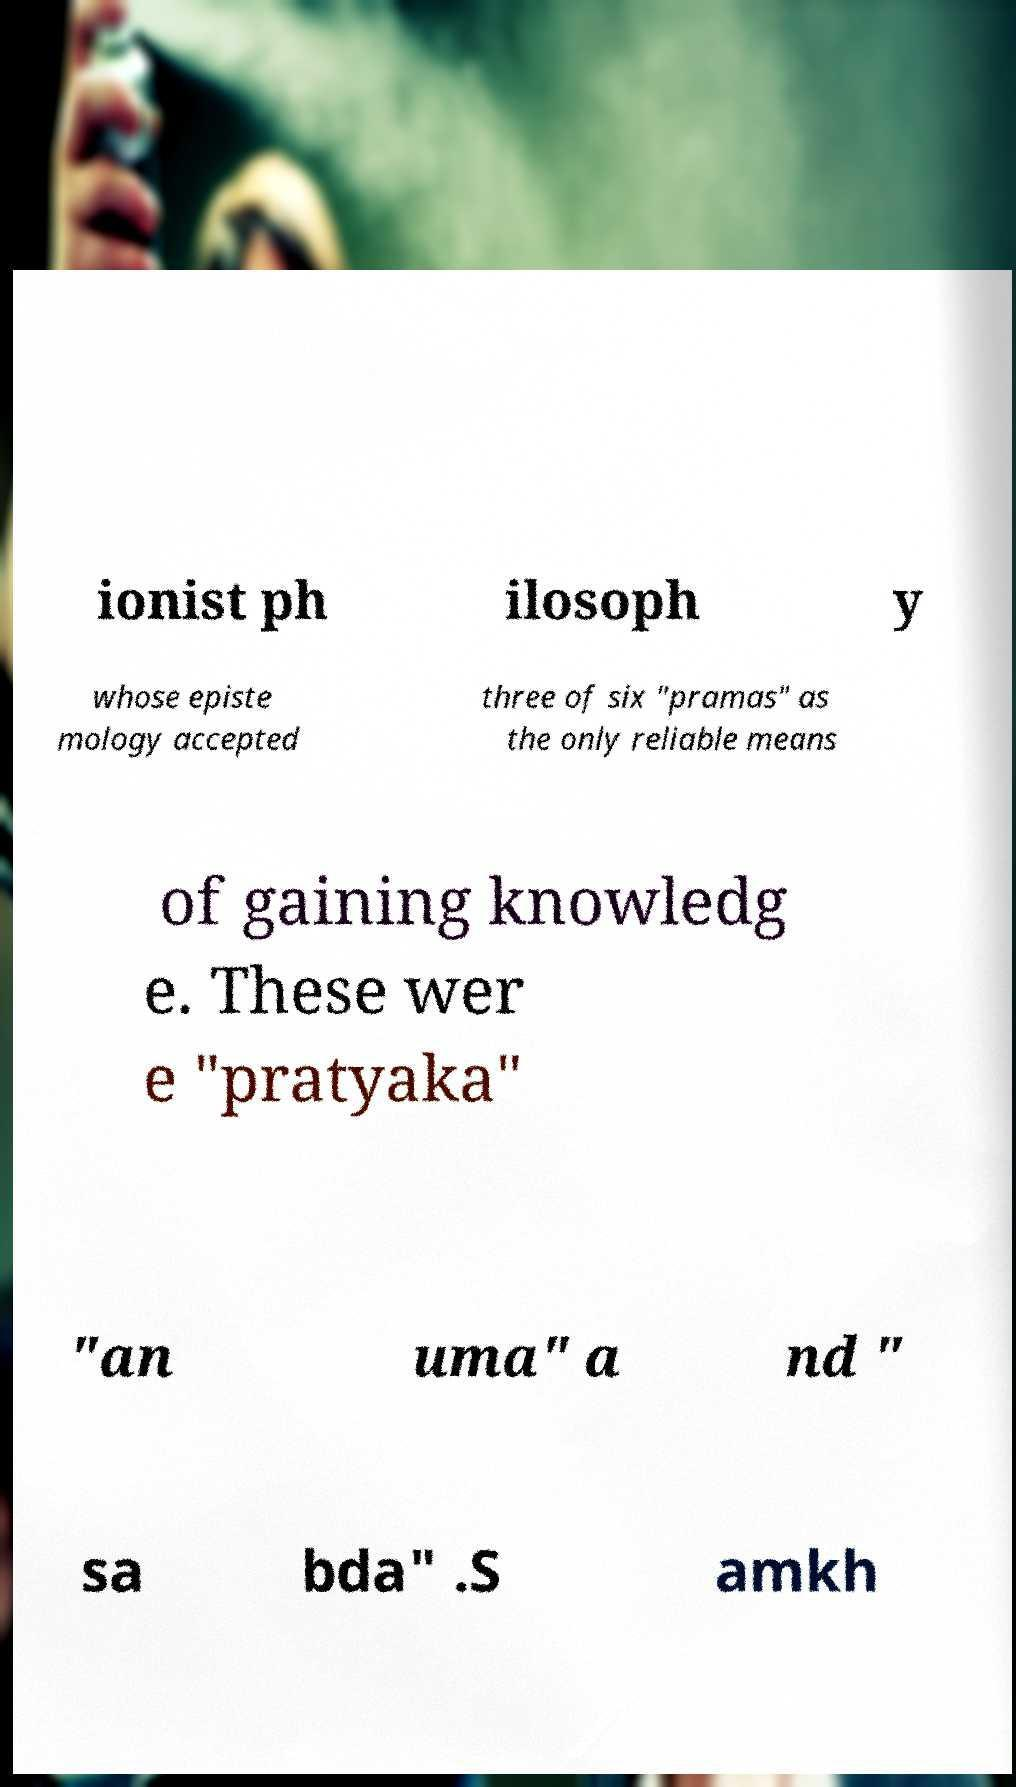I need the written content from this picture converted into text. Can you do that? ionist ph ilosoph y whose episte mology accepted three of six "pramas" as the only reliable means of gaining knowledg e. These wer e "pratyaka" "an uma" a nd " sa bda" .S amkh 